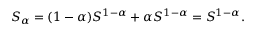<formula> <loc_0><loc_0><loc_500><loc_500>\begin{array} { r } { S _ { \alpha } = ( 1 - \alpha ) S ^ { 1 - \alpha } + \alpha S ^ { 1 - \alpha } = S ^ { 1 - \alpha } . } \end{array}</formula> 